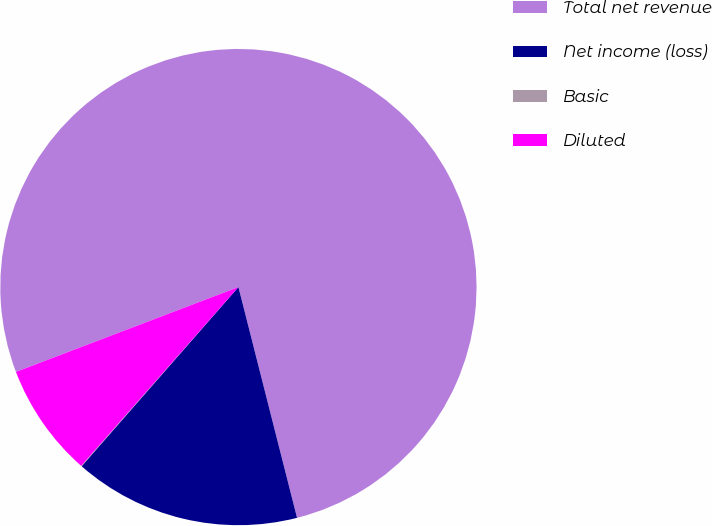Convert chart. <chart><loc_0><loc_0><loc_500><loc_500><pie_chart><fcel>Total net revenue<fcel>Net income (loss)<fcel>Basic<fcel>Diluted<nl><fcel>76.83%<fcel>15.4%<fcel>0.04%<fcel>7.72%<nl></chart> 